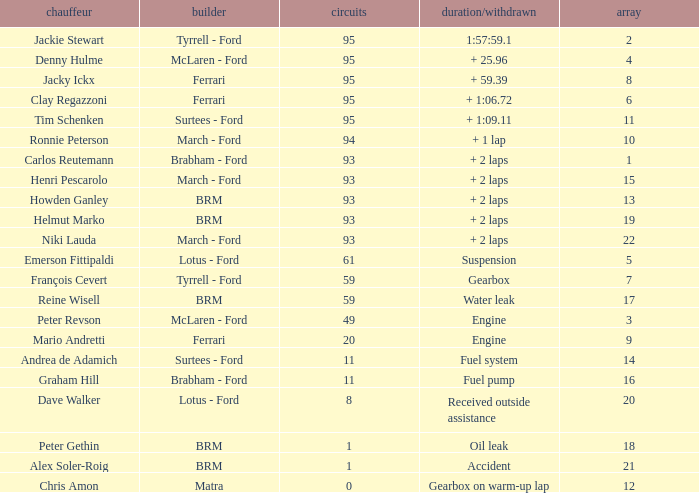What is the total number of grids for peter gethin? 18.0. 